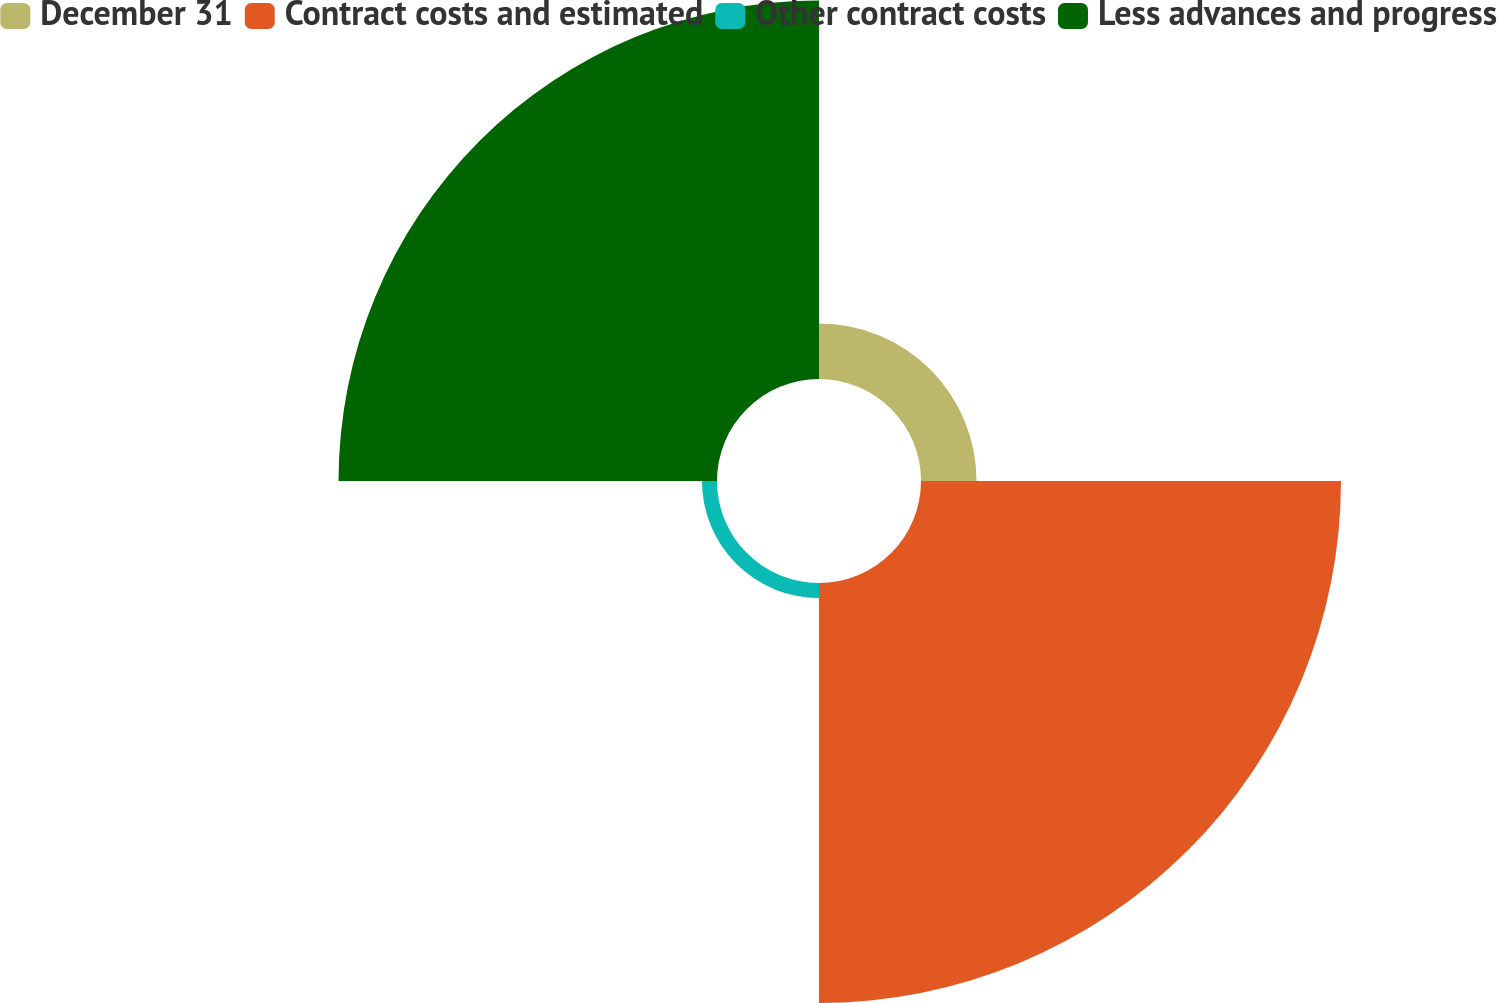<chart> <loc_0><loc_0><loc_500><loc_500><pie_chart><fcel>December 31<fcel>Contract costs and estimated<fcel>Other contract costs<fcel>Less advances and progress<nl><fcel>6.39%<fcel>48.33%<fcel>1.73%<fcel>43.55%<nl></chart> 